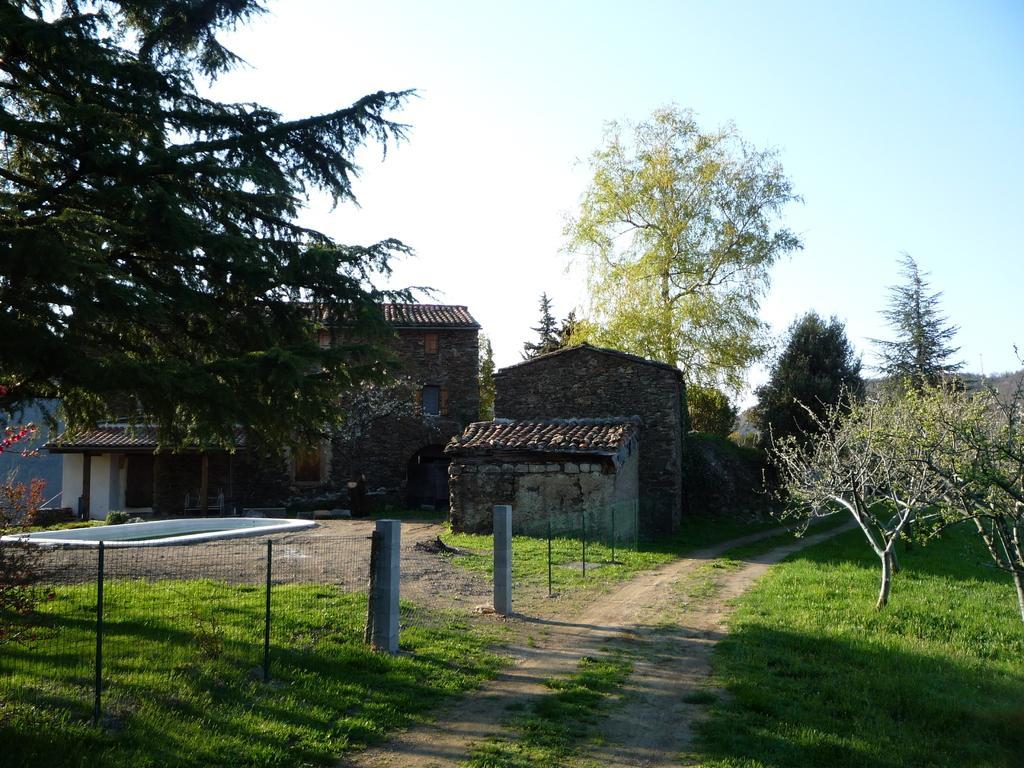Could you give a brief overview of what you see in this image? In this image we can see houses, trees, fencing, grass and we can also see the sky. 